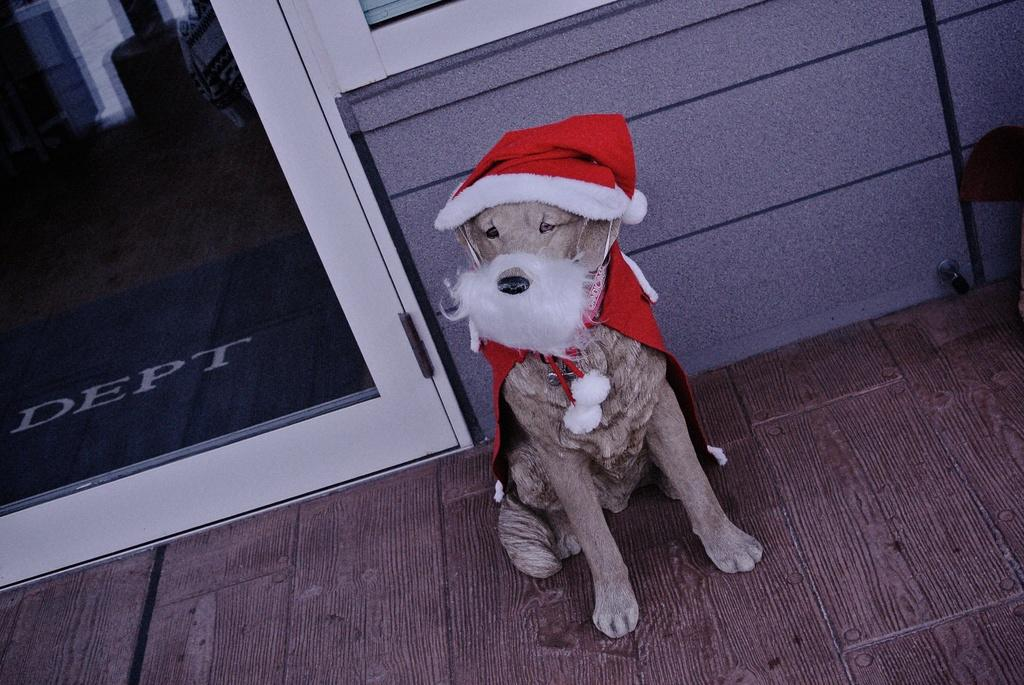What type of animal is in the picture? There is a dog in the picture. How is the dog dressed in the image? The dog is wearing a mask and cloth. Where is the dog sitting in the image? The dog is sitting near a door and a wall. What type of flooring is visible in the image? There is a wooden floor visible in the image. What type of fish can be seen swimming in the house in the image? There is no fish or house present in the image; it features a dog sitting near a door and a wall. 